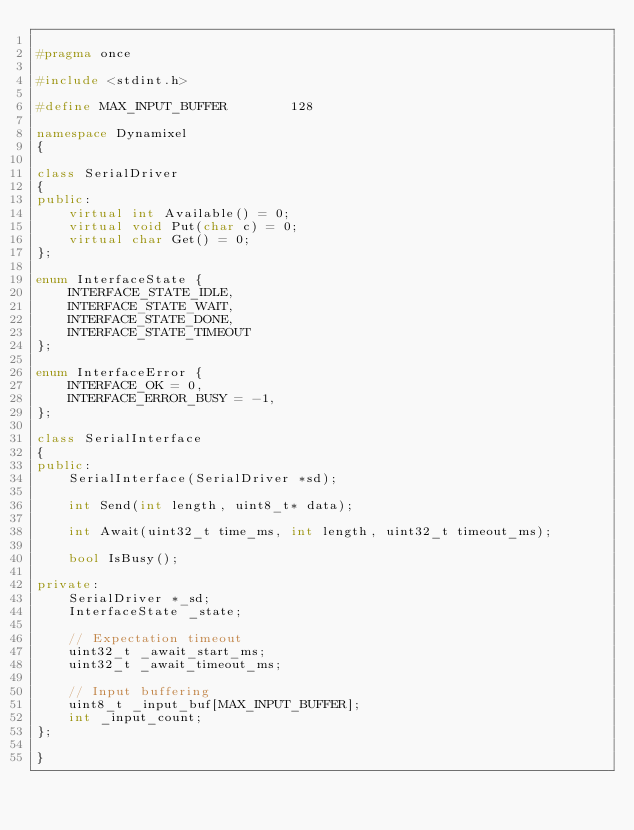<code> <loc_0><loc_0><loc_500><loc_500><_C++_>
#pragma once

#include <stdint.h>

#define MAX_INPUT_BUFFER        128

namespace Dynamixel
{

class SerialDriver
{
public:
    virtual int Available() = 0;
    virtual void Put(char c) = 0;
    virtual char Get() = 0;
};

enum InterfaceState {
    INTERFACE_STATE_IDLE,
    INTERFACE_STATE_WAIT,
    INTERFACE_STATE_DONE,
    INTERFACE_STATE_TIMEOUT
};

enum InterfaceError {
    INTERFACE_OK = 0,
    INTERFACE_ERROR_BUSY = -1,
};

class SerialInterface
{
public:
    SerialInterface(SerialDriver *sd);

    int Send(int length, uint8_t* data);

    int Await(uint32_t time_ms, int length, uint32_t timeout_ms);

    bool IsBusy();

private:
    SerialDriver *_sd;
    InterfaceState _state;

    // Expectation timeout
    uint32_t _await_start_ms;
    uint32_t _await_timeout_ms;

    // Input buffering
    uint8_t _input_buf[MAX_INPUT_BUFFER];
    int _input_count;
};

}

</code> 